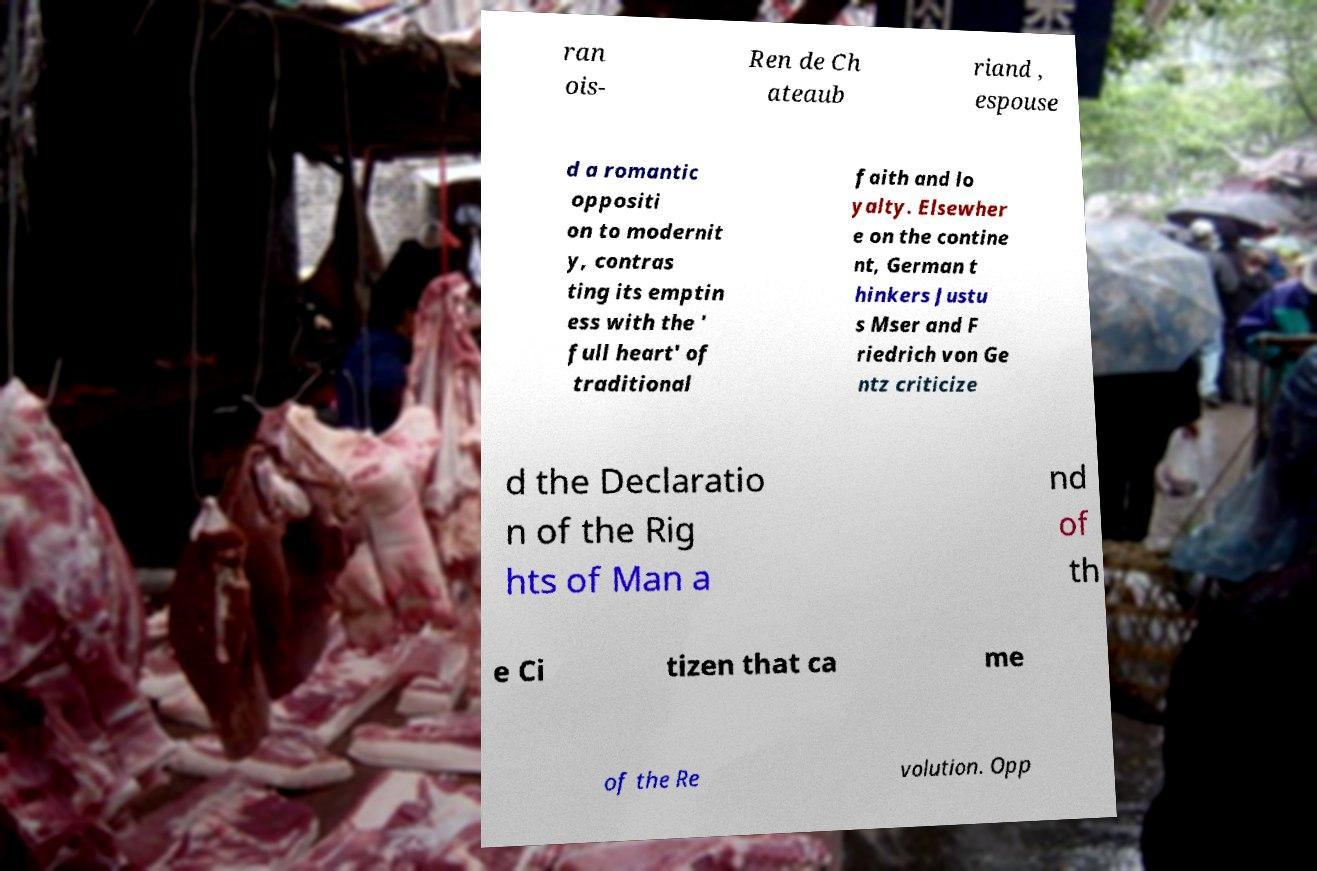Could you assist in decoding the text presented in this image and type it out clearly? ran ois- Ren de Ch ateaub riand , espouse d a romantic oppositi on to modernit y, contras ting its emptin ess with the ' full heart' of traditional faith and lo yalty. Elsewher e on the contine nt, German t hinkers Justu s Mser and F riedrich von Ge ntz criticize d the Declaratio n of the Rig hts of Man a nd of th e Ci tizen that ca me of the Re volution. Opp 